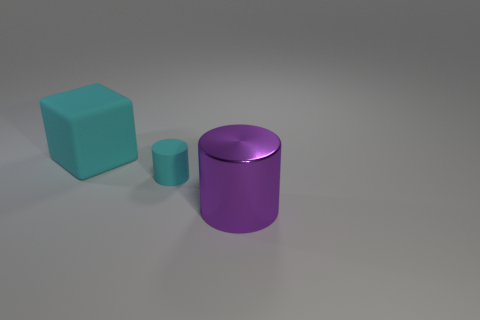Subtract all cyan cylinders. How many cylinders are left? 1 Subtract all brown spheres. How many cyan cylinders are left? 1 Add 2 small cyan objects. How many objects exist? 5 Subtract 2 cylinders. How many cylinders are left? 0 Subtract all small green objects. Subtract all large cyan things. How many objects are left? 2 Add 1 cyan rubber things. How many cyan rubber things are left? 3 Add 1 tiny objects. How many tiny objects exist? 2 Subtract 0 yellow spheres. How many objects are left? 3 Subtract all cubes. How many objects are left? 2 Subtract all gray cylinders. Subtract all purple balls. How many cylinders are left? 2 